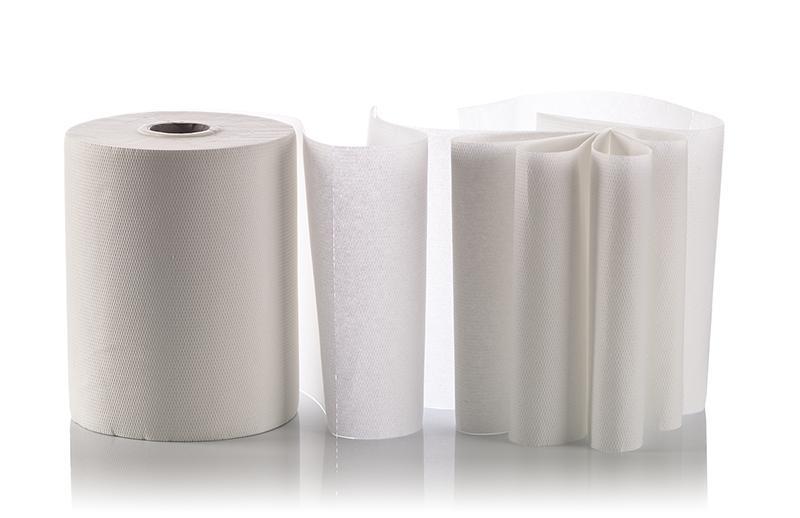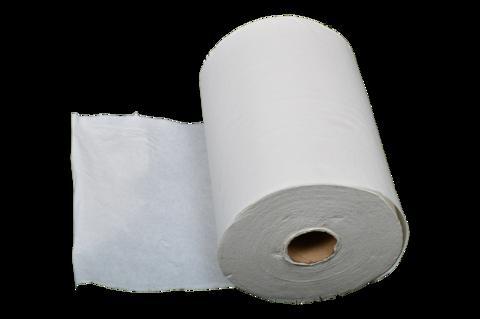The first image is the image on the left, the second image is the image on the right. Analyze the images presented: Is the assertion "A towel roll is held vertically on a stand with a silver base." valid? Answer yes or no. No. 